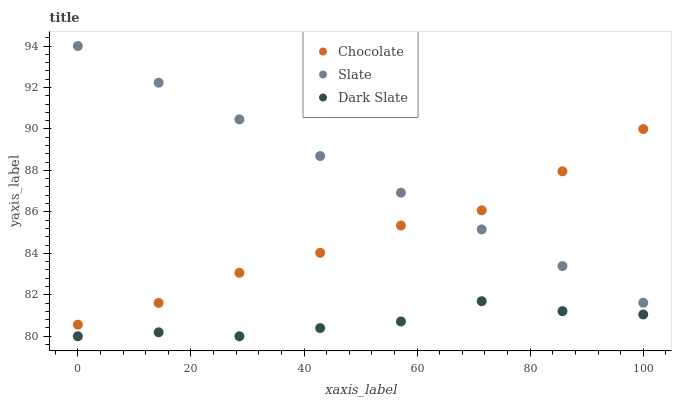Does Dark Slate have the minimum area under the curve?
Answer yes or no. Yes. Does Slate have the maximum area under the curve?
Answer yes or no. Yes. Does Chocolate have the minimum area under the curve?
Answer yes or no. No. Does Chocolate have the maximum area under the curve?
Answer yes or no. No. Is Slate the smoothest?
Answer yes or no. Yes. Is Dark Slate the roughest?
Answer yes or no. Yes. Is Chocolate the smoothest?
Answer yes or no. No. Is Chocolate the roughest?
Answer yes or no. No. Does Dark Slate have the lowest value?
Answer yes or no. Yes. Does Chocolate have the lowest value?
Answer yes or no. No. Does Slate have the highest value?
Answer yes or no. Yes. Does Chocolate have the highest value?
Answer yes or no. No. Is Dark Slate less than Chocolate?
Answer yes or no. Yes. Is Chocolate greater than Dark Slate?
Answer yes or no. Yes. Does Chocolate intersect Slate?
Answer yes or no. Yes. Is Chocolate less than Slate?
Answer yes or no. No. Is Chocolate greater than Slate?
Answer yes or no. No. Does Dark Slate intersect Chocolate?
Answer yes or no. No. 